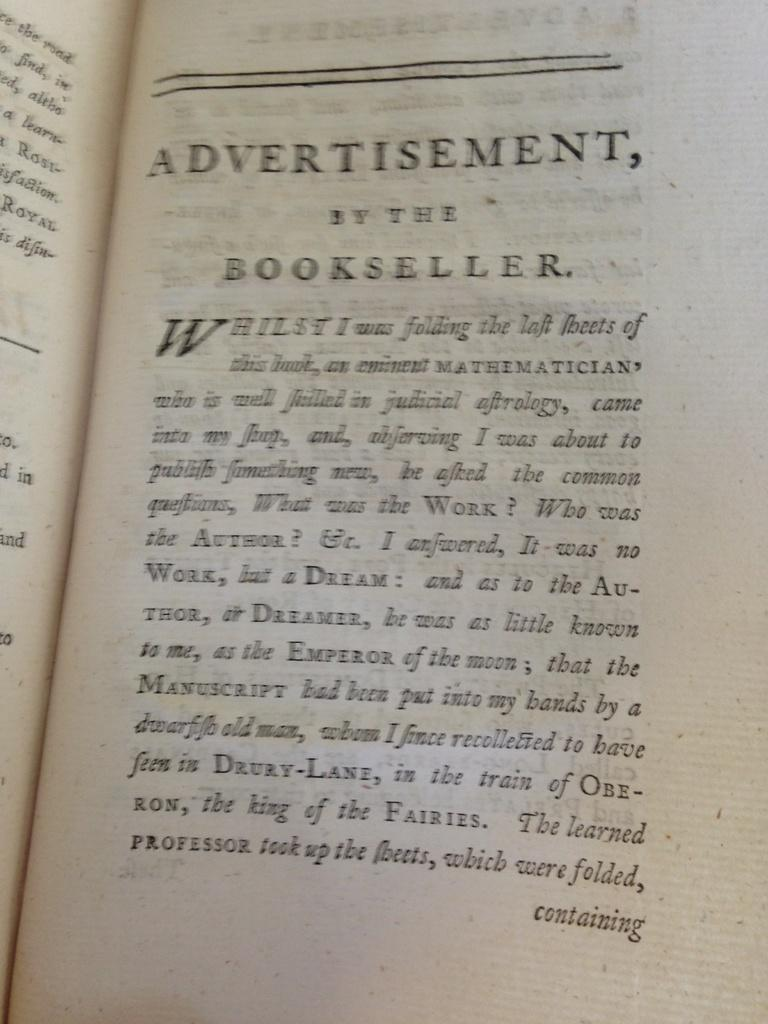<image>
Give a short and clear explanation of the subsequent image. Page of a book with the title "Advertisement, By The Bookseller". 